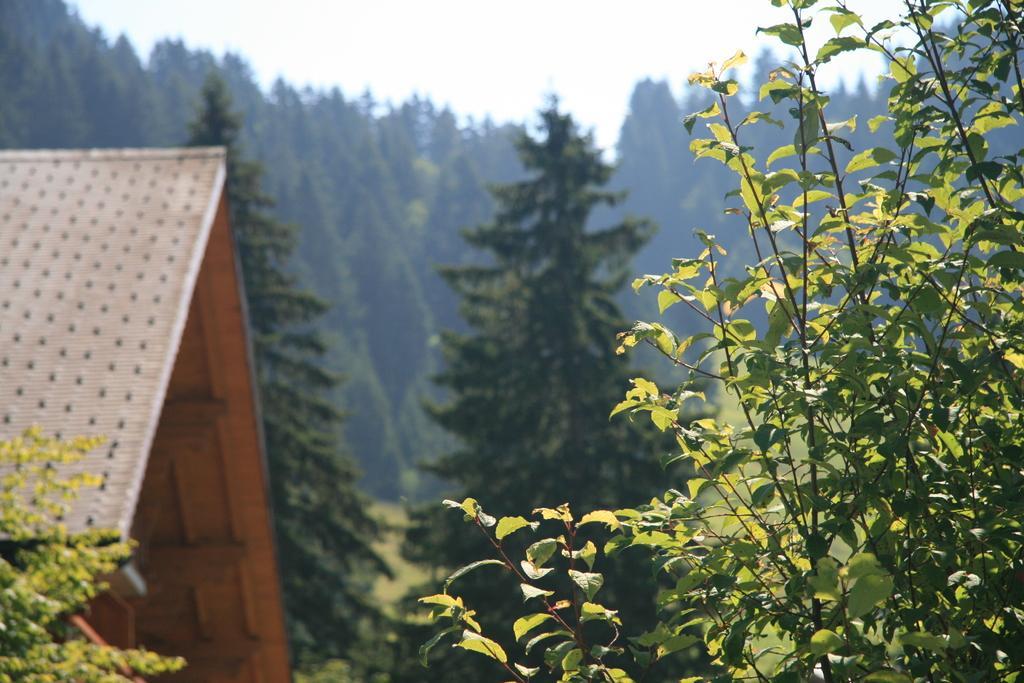Could you give a brief overview of what you see in this image? In this image we can see sky, house, trees and plants. 